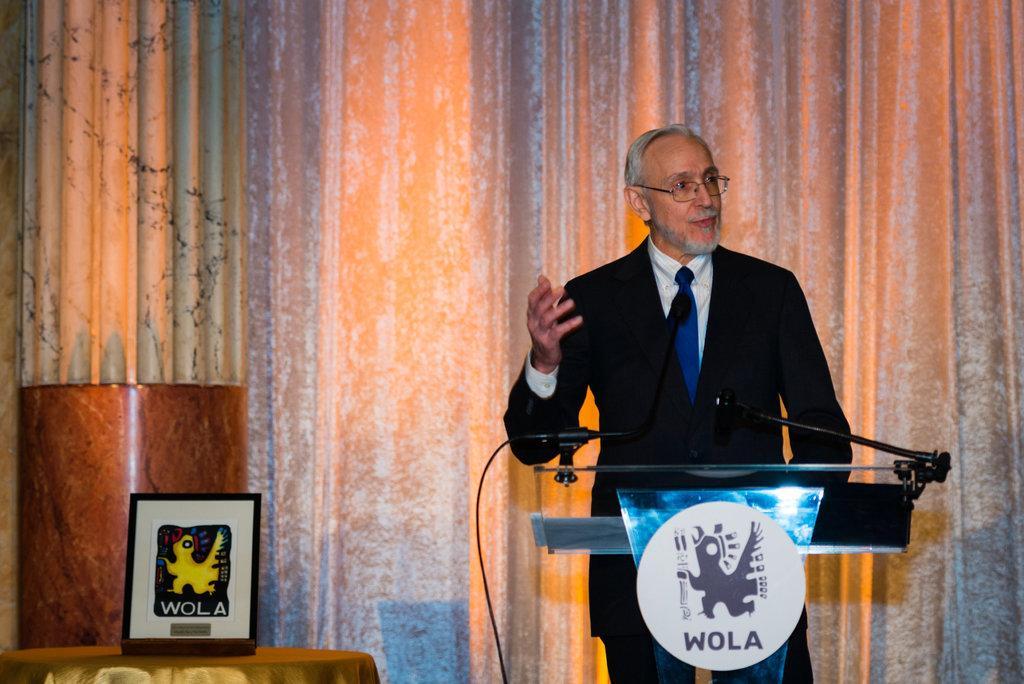Please provide a concise description of this image. In this picture we can see a man in the black blazer is standing behind the podium. On the podium there is a logo and microphones. On the left side of the podium there is a photo frame on an object. Behind the man, those are looking like curtains. 